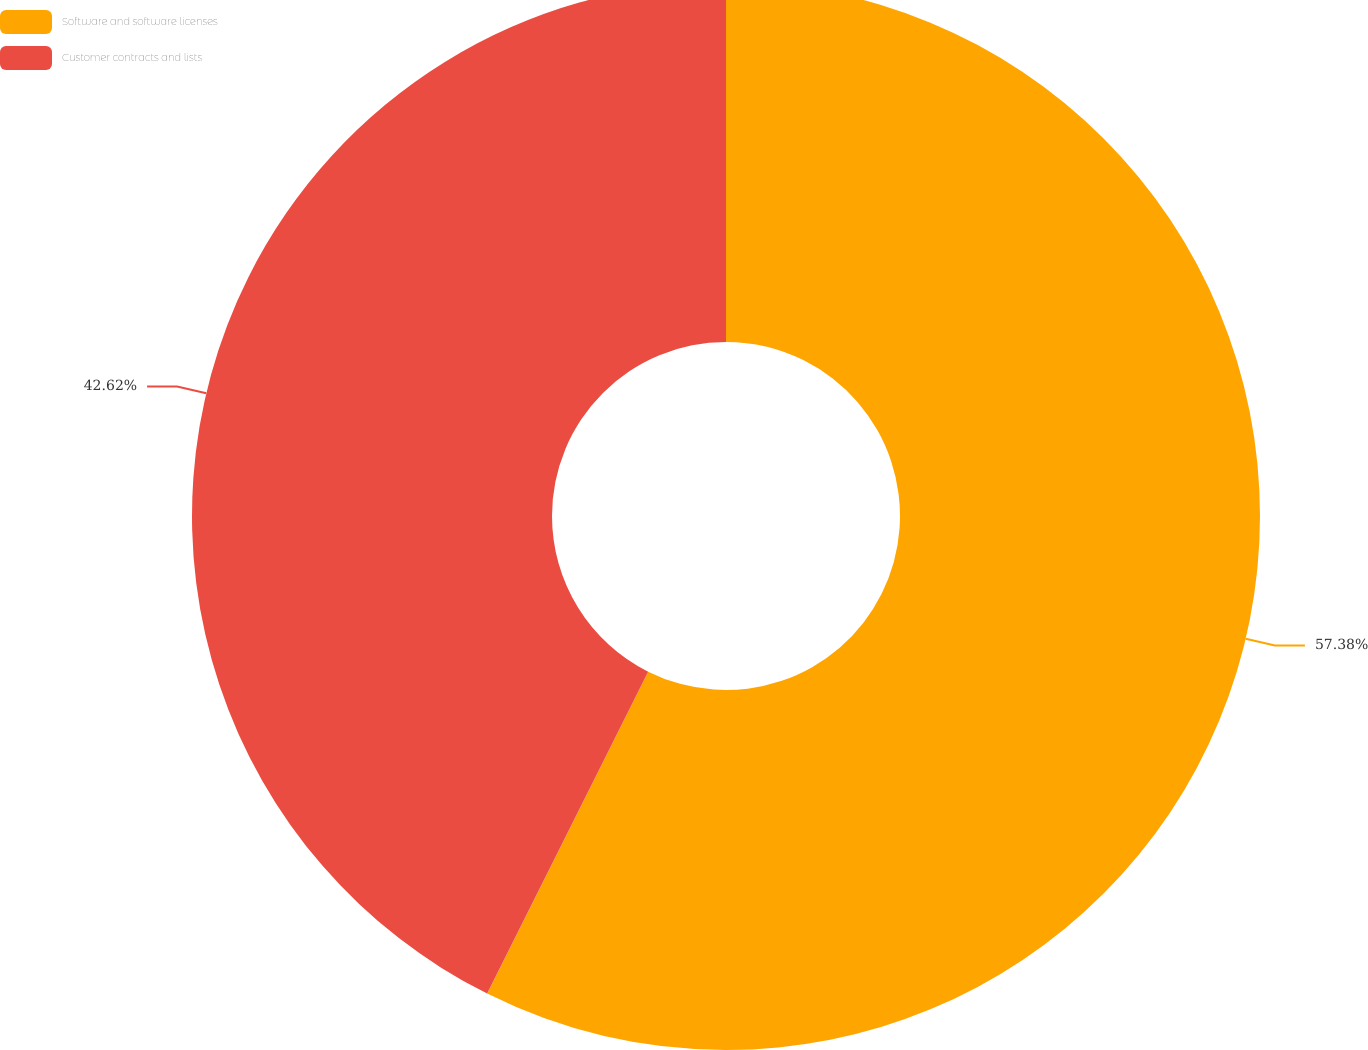Convert chart. <chart><loc_0><loc_0><loc_500><loc_500><pie_chart><fcel>Software and software licenses<fcel>Customer contracts and lists<nl><fcel>57.38%<fcel>42.62%<nl></chart> 